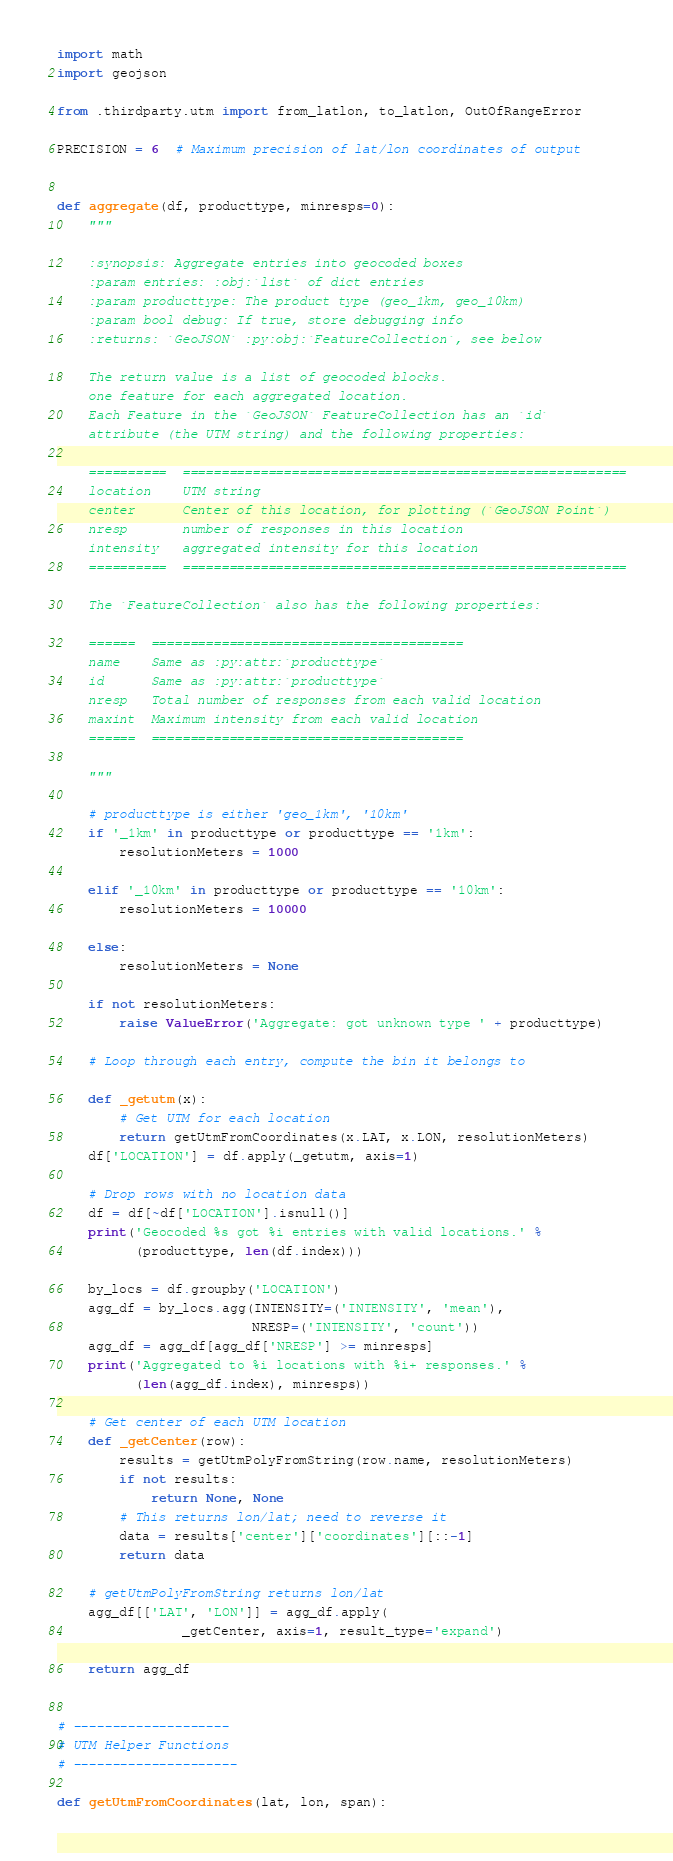Convert code to text. <code><loc_0><loc_0><loc_500><loc_500><_Python_>import math
import geojson

from .thirdparty.utm import from_latlon, to_latlon, OutOfRangeError

PRECISION = 6  # Maximum precision of lat/lon coordinates of output


def aggregate(df, producttype, minresps=0):
    """

    :synopsis: Aggregate entries into geocoded boxes
    :param entries: :obj:`list` of dict entries
    :param producttype: The product type (geo_1km, geo_10km)
    :param bool debug: If true, store debugging info
    :returns: `GeoJSON` :py:obj:`FeatureCollection`, see below

    The return value is a list of geocoded blocks.
    one feature for each aggregated location.
    Each Feature in the `GeoJSON` FeatureCollection has an `id`
    attribute (the UTM string) and the following properties:

    ==========  =========================================================
    location    UTM string
    center      Center of this location, for plotting (`GeoJSON Point`)
    nresp       number of responses in this location
    intensity   aggregated intensity for this location
    ==========  =========================================================

    The `FeatureCollection` also has the following properties:

    ======  ========================================
    name    Same as :py:attr:`producttype`
    id      Same as :py:attr:`producttype`
    nresp   Total number of responses from each valid location
    maxint  Maximum intensity from each valid location
    ======  ========================================

    """

    # producttype is either 'geo_1km', '10km'
    if '_1km' in producttype or producttype == '1km':
        resolutionMeters = 1000

    elif '_10km' in producttype or producttype == '10km':
        resolutionMeters = 10000

    else:
        resolutionMeters = None

    if not resolutionMeters:
        raise ValueError('Aggregate: got unknown type ' + producttype)

    # Loop through each entry, compute the bin it belongs to

    def _getutm(x):
        # Get UTM for each location
        return getUtmFromCoordinates(x.LAT, x.LON, resolutionMeters)
    df['LOCATION'] = df.apply(_getutm, axis=1)

    # Drop rows with no location data
    df = df[~df['LOCATION'].isnull()]
    print('Geocoded %s got %i entries with valid locations.' %
          (producttype, len(df.index)))

    by_locs = df.groupby('LOCATION')
    agg_df = by_locs.agg(INTENSITY=('INTENSITY', 'mean'),
                         NRESP=('INTENSITY', 'count'))
    agg_df = agg_df[agg_df['NRESP'] >= minresps]
    print('Aggregated to %i locations with %i+ responses.' %
          (len(agg_df.index), minresps))

    # Get center of each UTM location
    def _getCenter(row):
        results = getUtmPolyFromString(row.name, resolutionMeters)
        if not results:
            return None, None
        # This returns lon/lat; need to reverse it
        data = results['center']['coordinates'][::-1]
        return data

    # getUtmPolyFromString returns lon/lat
    agg_df[['LAT', 'LON']] = agg_df.apply(
                _getCenter, axis=1, result_type='expand')

    return agg_df


# --------------------
# UTM Helper Functions
# ---------------------

def getUtmFromCoordinates(lat, lon, span):</code> 